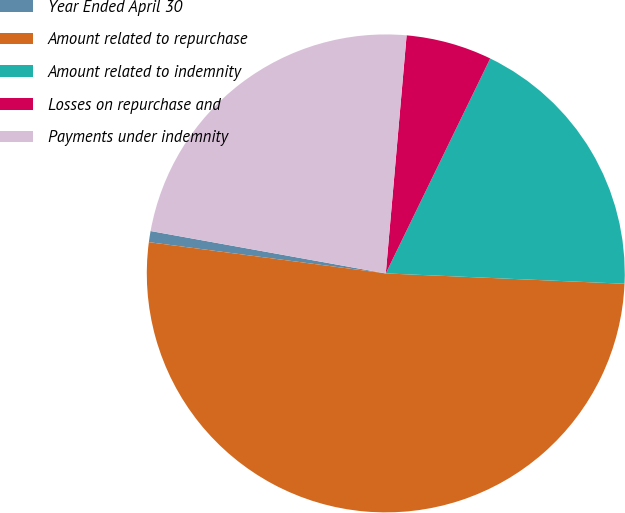Convert chart. <chart><loc_0><loc_0><loc_500><loc_500><pie_chart><fcel>Year Ended April 30<fcel>Amount related to repurchase<fcel>Amount related to indemnity<fcel>Losses on repurchase and<fcel>Payments under indemnity<nl><fcel>0.75%<fcel>51.4%<fcel>18.49%<fcel>5.81%<fcel>23.55%<nl></chart> 